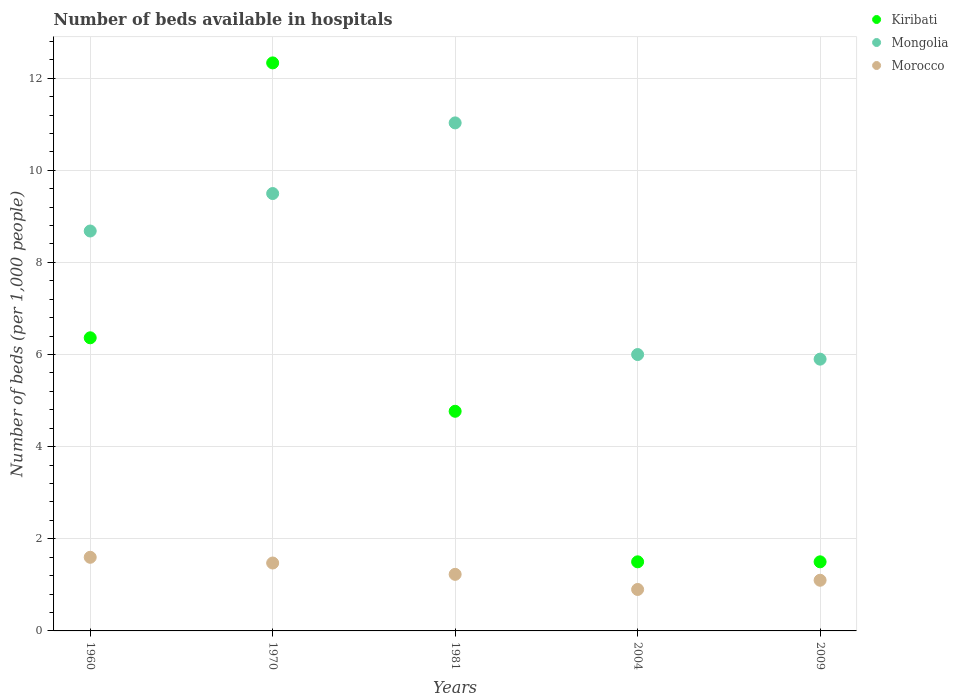Is the number of dotlines equal to the number of legend labels?
Give a very brief answer. Yes. What is the number of beds in the hospiatls of in Mongolia in 1970?
Your answer should be compact. 9.5. Across all years, what is the maximum number of beds in the hospiatls of in Mongolia?
Ensure brevity in your answer.  11.03. In which year was the number of beds in the hospiatls of in Kiribati minimum?
Your response must be concise. 2004. What is the total number of beds in the hospiatls of in Morocco in the graph?
Ensure brevity in your answer.  6.3. What is the difference between the number of beds in the hospiatls of in Kiribati in 1960 and that in 2009?
Offer a terse response. 4.86. What is the difference between the number of beds in the hospiatls of in Kiribati in 1981 and the number of beds in the hospiatls of in Mongolia in 1970?
Make the answer very short. -4.73. What is the average number of beds in the hospiatls of in Kiribati per year?
Your answer should be compact. 5.29. In the year 1981, what is the difference between the number of beds in the hospiatls of in Mongolia and number of beds in the hospiatls of in Kiribati?
Your answer should be very brief. 6.26. What is the ratio of the number of beds in the hospiatls of in Kiribati in 2004 to that in 2009?
Offer a terse response. 1. Is the number of beds in the hospiatls of in Morocco in 1970 less than that in 2009?
Provide a short and direct response. No. Is the difference between the number of beds in the hospiatls of in Mongolia in 1960 and 1981 greater than the difference between the number of beds in the hospiatls of in Kiribati in 1960 and 1981?
Make the answer very short. No. What is the difference between the highest and the second highest number of beds in the hospiatls of in Mongolia?
Your response must be concise. 1.53. What is the difference between the highest and the lowest number of beds in the hospiatls of in Kiribati?
Ensure brevity in your answer.  10.83. Is the sum of the number of beds in the hospiatls of in Morocco in 1981 and 2004 greater than the maximum number of beds in the hospiatls of in Mongolia across all years?
Make the answer very short. No. Is the number of beds in the hospiatls of in Kiribati strictly less than the number of beds in the hospiatls of in Morocco over the years?
Your answer should be very brief. No. How many dotlines are there?
Your answer should be very brief. 3. How many years are there in the graph?
Offer a terse response. 5. What is the difference between two consecutive major ticks on the Y-axis?
Give a very brief answer. 2. Does the graph contain any zero values?
Your answer should be compact. No. Does the graph contain grids?
Offer a terse response. Yes. Where does the legend appear in the graph?
Make the answer very short. Top right. What is the title of the graph?
Your response must be concise. Number of beds available in hospitals. Does "Armenia" appear as one of the legend labels in the graph?
Offer a very short reply. No. What is the label or title of the X-axis?
Offer a very short reply. Years. What is the label or title of the Y-axis?
Keep it short and to the point. Number of beds (per 1,0 people). What is the Number of beds (per 1,000 people) of Kiribati in 1960?
Provide a short and direct response. 6.36. What is the Number of beds (per 1,000 people) of Mongolia in 1960?
Offer a very short reply. 8.68. What is the Number of beds (per 1,000 people) in Morocco in 1960?
Your answer should be compact. 1.6. What is the Number of beds (per 1,000 people) in Kiribati in 1970?
Provide a succinct answer. 12.33. What is the Number of beds (per 1,000 people) in Mongolia in 1970?
Your answer should be compact. 9.5. What is the Number of beds (per 1,000 people) in Morocco in 1970?
Your response must be concise. 1.47. What is the Number of beds (per 1,000 people) in Kiribati in 1981?
Offer a very short reply. 4.77. What is the Number of beds (per 1,000 people) in Mongolia in 1981?
Offer a very short reply. 11.03. What is the Number of beds (per 1,000 people) of Morocco in 1981?
Make the answer very short. 1.23. What is the Number of beds (per 1,000 people) in Morocco in 2004?
Provide a succinct answer. 0.9. What is the Number of beds (per 1,000 people) of Mongolia in 2009?
Make the answer very short. 5.9. Across all years, what is the maximum Number of beds (per 1,000 people) in Kiribati?
Give a very brief answer. 12.33. Across all years, what is the maximum Number of beds (per 1,000 people) in Mongolia?
Provide a short and direct response. 11.03. Across all years, what is the maximum Number of beds (per 1,000 people) of Morocco?
Offer a very short reply. 1.6. Across all years, what is the minimum Number of beds (per 1,000 people) of Mongolia?
Your answer should be compact. 5.9. Across all years, what is the minimum Number of beds (per 1,000 people) in Morocco?
Provide a short and direct response. 0.9. What is the total Number of beds (per 1,000 people) of Kiribati in the graph?
Ensure brevity in your answer.  26.46. What is the total Number of beds (per 1,000 people) of Mongolia in the graph?
Offer a terse response. 41.11. What is the total Number of beds (per 1,000 people) in Morocco in the graph?
Ensure brevity in your answer.  6.3. What is the difference between the Number of beds (per 1,000 people) in Kiribati in 1960 and that in 1970?
Your answer should be very brief. -5.97. What is the difference between the Number of beds (per 1,000 people) in Mongolia in 1960 and that in 1970?
Offer a very short reply. -0.81. What is the difference between the Number of beds (per 1,000 people) of Morocco in 1960 and that in 1970?
Your answer should be compact. 0.12. What is the difference between the Number of beds (per 1,000 people) of Kiribati in 1960 and that in 1981?
Offer a terse response. 1.6. What is the difference between the Number of beds (per 1,000 people) in Mongolia in 1960 and that in 1981?
Your response must be concise. -2.35. What is the difference between the Number of beds (per 1,000 people) of Morocco in 1960 and that in 1981?
Your response must be concise. 0.37. What is the difference between the Number of beds (per 1,000 people) in Kiribati in 1960 and that in 2004?
Ensure brevity in your answer.  4.86. What is the difference between the Number of beds (per 1,000 people) of Mongolia in 1960 and that in 2004?
Make the answer very short. 2.68. What is the difference between the Number of beds (per 1,000 people) in Morocco in 1960 and that in 2004?
Offer a terse response. 0.7. What is the difference between the Number of beds (per 1,000 people) of Kiribati in 1960 and that in 2009?
Your answer should be very brief. 4.86. What is the difference between the Number of beds (per 1,000 people) in Mongolia in 1960 and that in 2009?
Offer a terse response. 2.78. What is the difference between the Number of beds (per 1,000 people) in Morocco in 1960 and that in 2009?
Give a very brief answer. 0.5. What is the difference between the Number of beds (per 1,000 people) in Kiribati in 1970 and that in 1981?
Provide a short and direct response. 7.56. What is the difference between the Number of beds (per 1,000 people) of Mongolia in 1970 and that in 1981?
Offer a very short reply. -1.53. What is the difference between the Number of beds (per 1,000 people) of Morocco in 1970 and that in 1981?
Provide a succinct answer. 0.25. What is the difference between the Number of beds (per 1,000 people) of Kiribati in 1970 and that in 2004?
Make the answer very short. 10.83. What is the difference between the Number of beds (per 1,000 people) of Mongolia in 1970 and that in 2004?
Keep it short and to the point. 3.5. What is the difference between the Number of beds (per 1,000 people) in Morocco in 1970 and that in 2004?
Provide a succinct answer. 0.57. What is the difference between the Number of beds (per 1,000 people) of Kiribati in 1970 and that in 2009?
Ensure brevity in your answer.  10.83. What is the difference between the Number of beds (per 1,000 people) of Mongolia in 1970 and that in 2009?
Provide a short and direct response. 3.6. What is the difference between the Number of beds (per 1,000 people) of Morocco in 1970 and that in 2009?
Ensure brevity in your answer.  0.37. What is the difference between the Number of beds (per 1,000 people) of Kiribati in 1981 and that in 2004?
Ensure brevity in your answer.  3.27. What is the difference between the Number of beds (per 1,000 people) of Mongolia in 1981 and that in 2004?
Your answer should be very brief. 5.03. What is the difference between the Number of beds (per 1,000 people) of Morocco in 1981 and that in 2004?
Offer a terse response. 0.33. What is the difference between the Number of beds (per 1,000 people) in Kiribati in 1981 and that in 2009?
Your answer should be compact. 3.27. What is the difference between the Number of beds (per 1,000 people) in Mongolia in 1981 and that in 2009?
Provide a succinct answer. 5.13. What is the difference between the Number of beds (per 1,000 people) in Morocco in 1981 and that in 2009?
Provide a succinct answer. 0.13. What is the difference between the Number of beds (per 1,000 people) in Kiribati in 2004 and that in 2009?
Offer a terse response. 0. What is the difference between the Number of beds (per 1,000 people) of Mongolia in 2004 and that in 2009?
Give a very brief answer. 0.1. What is the difference between the Number of beds (per 1,000 people) in Morocco in 2004 and that in 2009?
Keep it short and to the point. -0.2. What is the difference between the Number of beds (per 1,000 people) in Kiribati in 1960 and the Number of beds (per 1,000 people) in Mongolia in 1970?
Make the answer very short. -3.13. What is the difference between the Number of beds (per 1,000 people) of Kiribati in 1960 and the Number of beds (per 1,000 people) of Morocco in 1970?
Offer a very short reply. 4.89. What is the difference between the Number of beds (per 1,000 people) of Mongolia in 1960 and the Number of beds (per 1,000 people) of Morocco in 1970?
Make the answer very short. 7.21. What is the difference between the Number of beds (per 1,000 people) in Kiribati in 1960 and the Number of beds (per 1,000 people) in Mongolia in 1981?
Ensure brevity in your answer.  -4.67. What is the difference between the Number of beds (per 1,000 people) in Kiribati in 1960 and the Number of beds (per 1,000 people) in Morocco in 1981?
Offer a very short reply. 5.14. What is the difference between the Number of beds (per 1,000 people) of Mongolia in 1960 and the Number of beds (per 1,000 people) of Morocco in 1981?
Your answer should be very brief. 7.45. What is the difference between the Number of beds (per 1,000 people) of Kiribati in 1960 and the Number of beds (per 1,000 people) of Mongolia in 2004?
Make the answer very short. 0.36. What is the difference between the Number of beds (per 1,000 people) of Kiribati in 1960 and the Number of beds (per 1,000 people) of Morocco in 2004?
Provide a succinct answer. 5.46. What is the difference between the Number of beds (per 1,000 people) in Mongolia in 1960 and the Number of beds (per 1,000 people) in Morocco in 2004?
Your answer should be compact. 7.78. What is the difference between the Number of beds (per 1,000 people) in Kiribati in 1960 and the Number of beds (per 1,000 people) in Mongolia in 2009?
Make the answer very short. 0.46. What is the difference between the Number of beds (per 1,000 people) in Kiribati in 1960 and the Number of beds (per 1,000 people) in Morocco in 2009?
Provide a short and direct response. 5.26. What is the difference between the Number of beds (per 1,000 people) of Mongolia in 1960 and the Number of beds (per 1,000 people) of Morocco in 2009?
Your answer should be very brief. 7.58. What is the difference between the Number of beds (per 1,000 people) of Kiribati in 1970 and the Number of beds (per 1,000 people) of Mongolia in 1981?
Offer a very short reply. 1.3. What is the difference between the Number of beds (per 1,000 people) in Kiribati in 1970 and the Number of beds (per 1,000 people) in Morocco in 1981?
Your response must be concise. 11.1. What is the difference between the Number of beds (per 1,000 people) in Mongolia in 1970 and the Number of beds (per 1,000 people) in Morocco in 1981?
Give a very brief answer. 8.27. What is the difference between the Number of beds (per 1,000 people) in Kiribati in 1970 and the Number of beds (per 1,000 people) in Mongolia in 2004?
Your response must be concise. 6.33. What is the difference between the Number of beds (per 1,000 people) in Kiribati in 1970 and the Number of beds (per 1,000 people) in Morocco in 2004?
Your answer should be very brief. 11.43. What is the difference between the Number of beds (per 1,000 people) of Mongolia in 1970 and the Number of beds (per 1,000 people) of Morocco in 2004?
Give a very brief answer. 8.6. What is the difference between the Number of beds (per 1,000 people) in Kiribati in 1970 and the Number of beds (per 1,000 people) in Mongolia in 2009?
Your answer should be very brief. 6.43. What is the difference between the Number of beds (per 1,000 people) in Kiribati in 1970 and the Number of beds (per 1,000 people) in Morocco in 2009?
Your response must be concise. 11.23. What is the difference between the Number of beds (per 1,000 people) of Mongolia in 1970 and the Number of beds (per 1,000 people) of Morocco in 2009?
Give a very brief answer. 8.4. What is the difference between the Number of beds (per 1,000 people) of Kiribati in 1981 and the Number of beds (per 1,000 people) of Mongolia in 2004?
Offer a very short reply. -1.23. What is the difference between the Number of beds (per 1,000 people) in Kiribati in 1981 and the Number of beds (per 1,000 people) in Morocco in 2004?
Make the answer very short. 3.87. What is the difference between the Number of beds (per 1,000 people) of Mongolia in 1981 and the Number of beds (per 1,000 people) of Morocco in 2004?
Ensure brevity in your answer.  10.13. What is the difference between the Number of beds (per 1,000 people) in Kiribati in 1981 and the Number of beds (per 1,000 people) in Mongolia in 2009?
Your response must be concise. -1.13. What is the difference between the Number of beds (per 1,000 people) of Kiribati in 1981 and the Number of beds (per 1,000 people) of Morocco in 2009?
Your answer should be compact. 3.67. What is the difference between the Number of beds (per 1,000 people) of Mongolia in 1981 and the Number of beds (per 1,000 people) of Morocco in 2009?
Make the answer very short. 9.93. What is the difference between the Number of beds (per 1,000 people) of Kiribati in 2004 and the Number of beds (per 1,000 people) of Mongolia in 2009?
Offer a terse response. -4.4. What is the difference between the Number of beds (per 1,000 people) of Kiribati in 2004 and the Number of beds (per 1,000 people) of Morocco in 2009?
Your answer should be very brief. 0.4. What is the average Number of beds (per 1,000 people) in Kiribati per year?
Make the answer very short. 5.29. What is the average Number of beds (per 1,000 people) of Mongolia per year?
Make the answer very short. 8.22. What is the average Number of beds (per 1,000 people) in Morocco per year?
Your answer should be very brief. 1.26. In the year 1960, what is the difference between the Number of beds (per 1,000 people) in Kiribati and Number of beds (per 1,000 people) in Mongolia?
Ensure brevity in your answer.  -2.32. In the year 1960, what is the difference between the Number of beds (per 1,000 people) of Kiribati and Number of beds (per 1,000 people) of Morocco?
Make the answer very short. 4.77. In the year 1960, what is the difference between the Number of beds (per 1,000 people) in Mongolia and Number of beds (per 1,000 people) in Morocco?
Offer a very short reply. 7.08. In the year 1970, what is the difference between the Number of beds (per 1,000 people) of Kiribati and Number of beds (per 1,000 people) of Mongolia?
Your response must be concise. 2.84. In the year 1970, what is the difference between the Number of beds (per 1,000 people) of Kiribati and Number of beds (per 1,000 people) of Morocco?
Make the answer very short. 10.86. In the year 1970, what is the difference between the Number of beds (per 1,000 people) of Mongolia and Number of beds (per 1,000 people) of Morocco?
Provide a short and direct response. 8.02. In the year 1981, what is the difference between the Number of beds (per 1,000 people) in Kiribati and Number of beds (per 1,000 people) in Mongolia?
Your answer should be very brief. -6.26. In the year 1981, what is the difference between the Number of beds (per 1,000 people) in Kiribati and Number of beds (per 1,000 people) in Morocco?
Your response must be concise. 3.54. In the year 1981, what is the difference between the Number of beds (per 1,000 people) of Mongolia and Number of beds (per 1,000 people) of Morocco?
Ensure brevity in your answer.  9.8. In the year 2004, what is the difference between the Number of beds (per 1,000 people) of Kiribati and Number of beds (per 1,000 people) of Mongolia?
Your answer should be compact. -4.5. In the year 2004, what is the difference between the Number of beds (per 1,000 people) in Mongolia and Number of beds (per 1,000 people) in Morocco?
Your answer should be compact. 5.1. In the year 2009, what is the difference between the Number of beds (per 1,000 people) of Kiribati and Number of beds (per 1,000 people) of Morocco?
Provide a succinct answer. 0.4. In the year 2009, what is the difference between the Number of beds (per 1,000 people) of Mongolia and Number of beds (per 1,000 people) of Morocco?
Your answer should be very brief. 4.8. What is the ratio of the Number of beds (per 1,000 people) of Kiribati in 1960 to that in 1970?
Ensure brevity in your answer.  0.52. What is the ratio of the Number of beds (per 1,000 people) in Mongolia in 1960 to that in 1970?
Keep it short and to the point. 0.91. What is the ratio of the Number of beds (per 1,000 people) in Morocco in 1960 to that in 1970?
Offer a very short reply. 1.08. What is the ratio of the Number of beds (per 1,000 people) of Kiribati in 1960 to that in 1981?
Give a very brief answer. 1.33. What is the ratio of the Number of beds (per 1,000 people) in Mongolia in 1960 to that in 1981?
Your answer should be very brief. 0.79. What is the ratio of the Number of beds (per 1,000 people) of Morocco in 1960 to that in 1981?
Give a very brief answer. 1.3. What is the ratio of the Number of beds (per 1,000 people) in Kiribati in 1960 to that in 2004?
Make the answer very short. 4.24. What is the ratio of the Number of beds (per 1,000 people) in Mongolia in 1960 to that in 2004?
Your answer should be very brief. 1.45. What is the ratio of the Number of beds (per 1,000 people) in Morocco in 1960 to that in 2004?
Keep it short and to the point. 1.78. What is the ratio of the Number of beds (per 1,000 people) of Kiribati in 1960 to that in 2009?
Ensure brevity in your answer.  4.24. What is the ratio of the Number of beds (per 1,000 people) in Mongolia in 1960 to that in 2009?
Your response must be concise. 1.47. What is the ratio of the Number of beds (per 1,000 people) of Morocco in 1960 to that in 2009?
Give a very brief answer. 1.45. What is the ratio of the Number of beds (per 1,000 people) of Kiribati in 1970 to that in 1981?
Your answer should be compact. 2.59. What is the ratio of the Number of beds (per 1,000 people) of Mongolia in 1970 to that in 1981?
Your response must be concise. 0.86. What is the ratio of the Number of beds (per 1,000 people) of Morocco in 1970 to that in 1981?
Your response must be concise. 1.2. What is the ratio of the Number of beds (per 1,000 people) of Kiribati in 1970 to that in 2004?
Offer a terse response. 8.22. What is the ratio of the Number of beds (per 1,000 people) in Mongolia in 1970 to that in 2004?
Provide a short and direct response. 1.58. What is the ratio of the Number of beds (per 1,000 people) of Morocco in 1970 to that in 2004?
Ensure brevity in your answer.  1.64. What is the ratio of the Number of beds (per 1,000 people) of Kiribati in 1970 to that in 2009?
Provide a succinct answer. 8.22. What is the ratio of the Number of beds (per 1,000 people) of Mongolia in 1970 to that in 2009?
Ensure brevity in your answer.  1.61. What is the ratio of the Number of beds (per 1,000 people) of Morocco in 1970 to that in 2009?
Keep it short and to the point. 1.34. What is the ratio of the Number of beds (per 1,000 people) of Kiribati in 1981 to that in 2004?
Your answer should be compact. 3.18. What is the ratio of the Number of beds (per 1,000 people) in Mongolia in 1981 to that in 2004?
Give a very brief answer. 1.84. What is the ratio of the Number of beds (per 1,000 people) of Morocco in 1981 to that in 2004?
Keep it short and to the point. 1.36. What is the ratio of the Number of beds (per 1,000 people) of Kiribati in 1981 to that in 2009?
Ensure brevity in your answer.  3.18. What is the ratio of the Number of beds (per 1,000 people) of Mongolia in 1981 to that in 2009?
Your response must be concise. 1.87. What is the ratio of the Number of beds (per 1,000 people) of Morocco in 1981 to that in 2009?
Ensure brevity in your answer.  1.12. What is the ratio of the Number of beds (per 1,000 people) in Mongolia in 2004 to that in 2009?
Keep it short and to the point. 1.02. What is the ratio of the Number of beds (per 1,000 people) of Morocco in 2004 to that in 2009?
Give a very brief answer. 0.82. What is the difference between the highest and the second highest Number of beds (per 1,000 people) of Kiribati?
Keep it short and to the point. 5.97. What is the difference between the highest and the second highest Number of beds (per 1,000 people) in Mongolia?
Ensure brevity in your answer.  1.53. What is the difference between the highest and the second highest Number of beds (per 1,000 people) in Morocco?
Your answer should be very brief. 0.12. What is the difference between the highest and the lowest Number of beds (per 1,000 people) in Kiribati?
Give a very brief answer. 10.83. What is the difference between the highest and the lowest Number of beds (per 1,000 people) of Mongolia?
Offer a terse response. 5.13. What is the difference between the highest and the lowest Number of beds (per 1,000 people) of Morocco?
Provide a short and direct response. 0.7. 